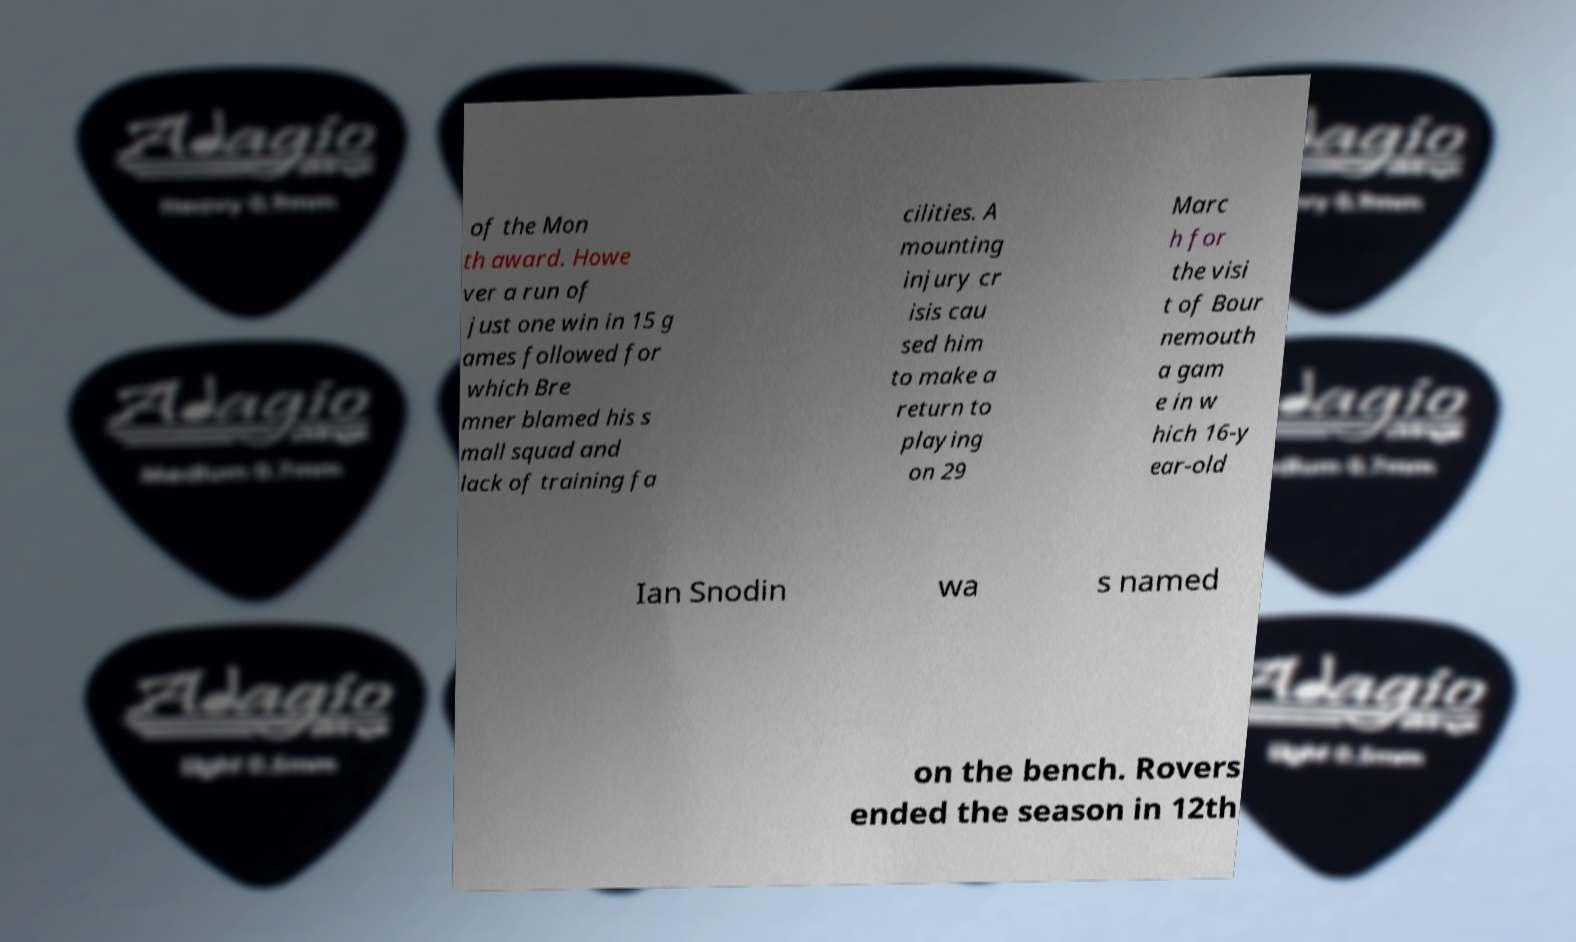For documentation purposes, I need the text within this image transcribed. Could you provide that? of the Mon th award. Howe ver a run of just one win in 15 g ames followed for which Bre mner blamed his s mall squad and lack of training fa cilities. A mounting injury cr isis cau sed him to make a return to playing on 29 Marc h for the visi t of Bour nemouth a gam e in w hich 16-y ear-old Ian Snodin wa s named on the bench. Rovers ended the season in 12th 